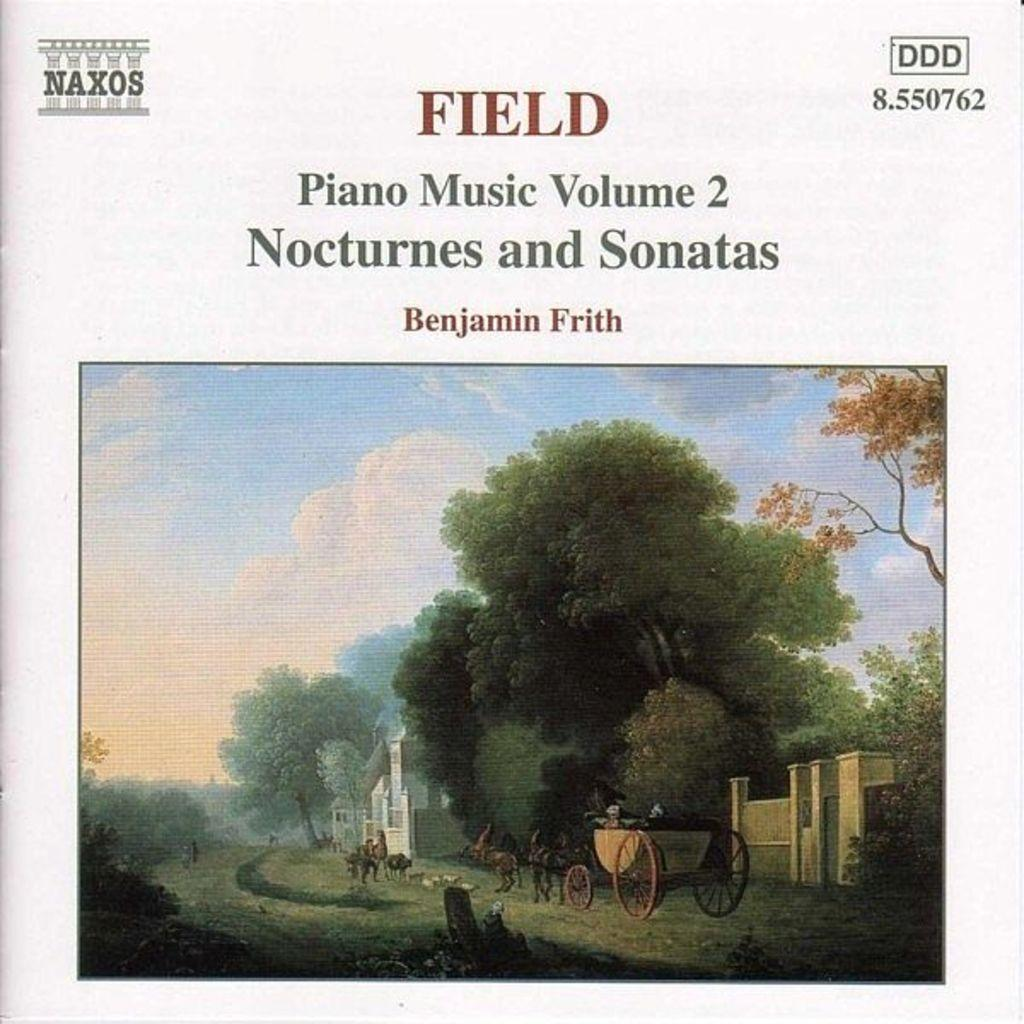What type of vegetation can be seen in the image? There are trees in the image. Is there any text present on the trees? Yes, there is text written on the trees. How would you describe the sky in the image? The sky is cloudy in the image. What is the ground covered with in the image? There is grass on the ground in the image. What type of iron is being used to stimulate the nerves in the image? There is no iron or reference to nerves present in the image; it features trees with text, a cloudy sky, and grass on the ground. 